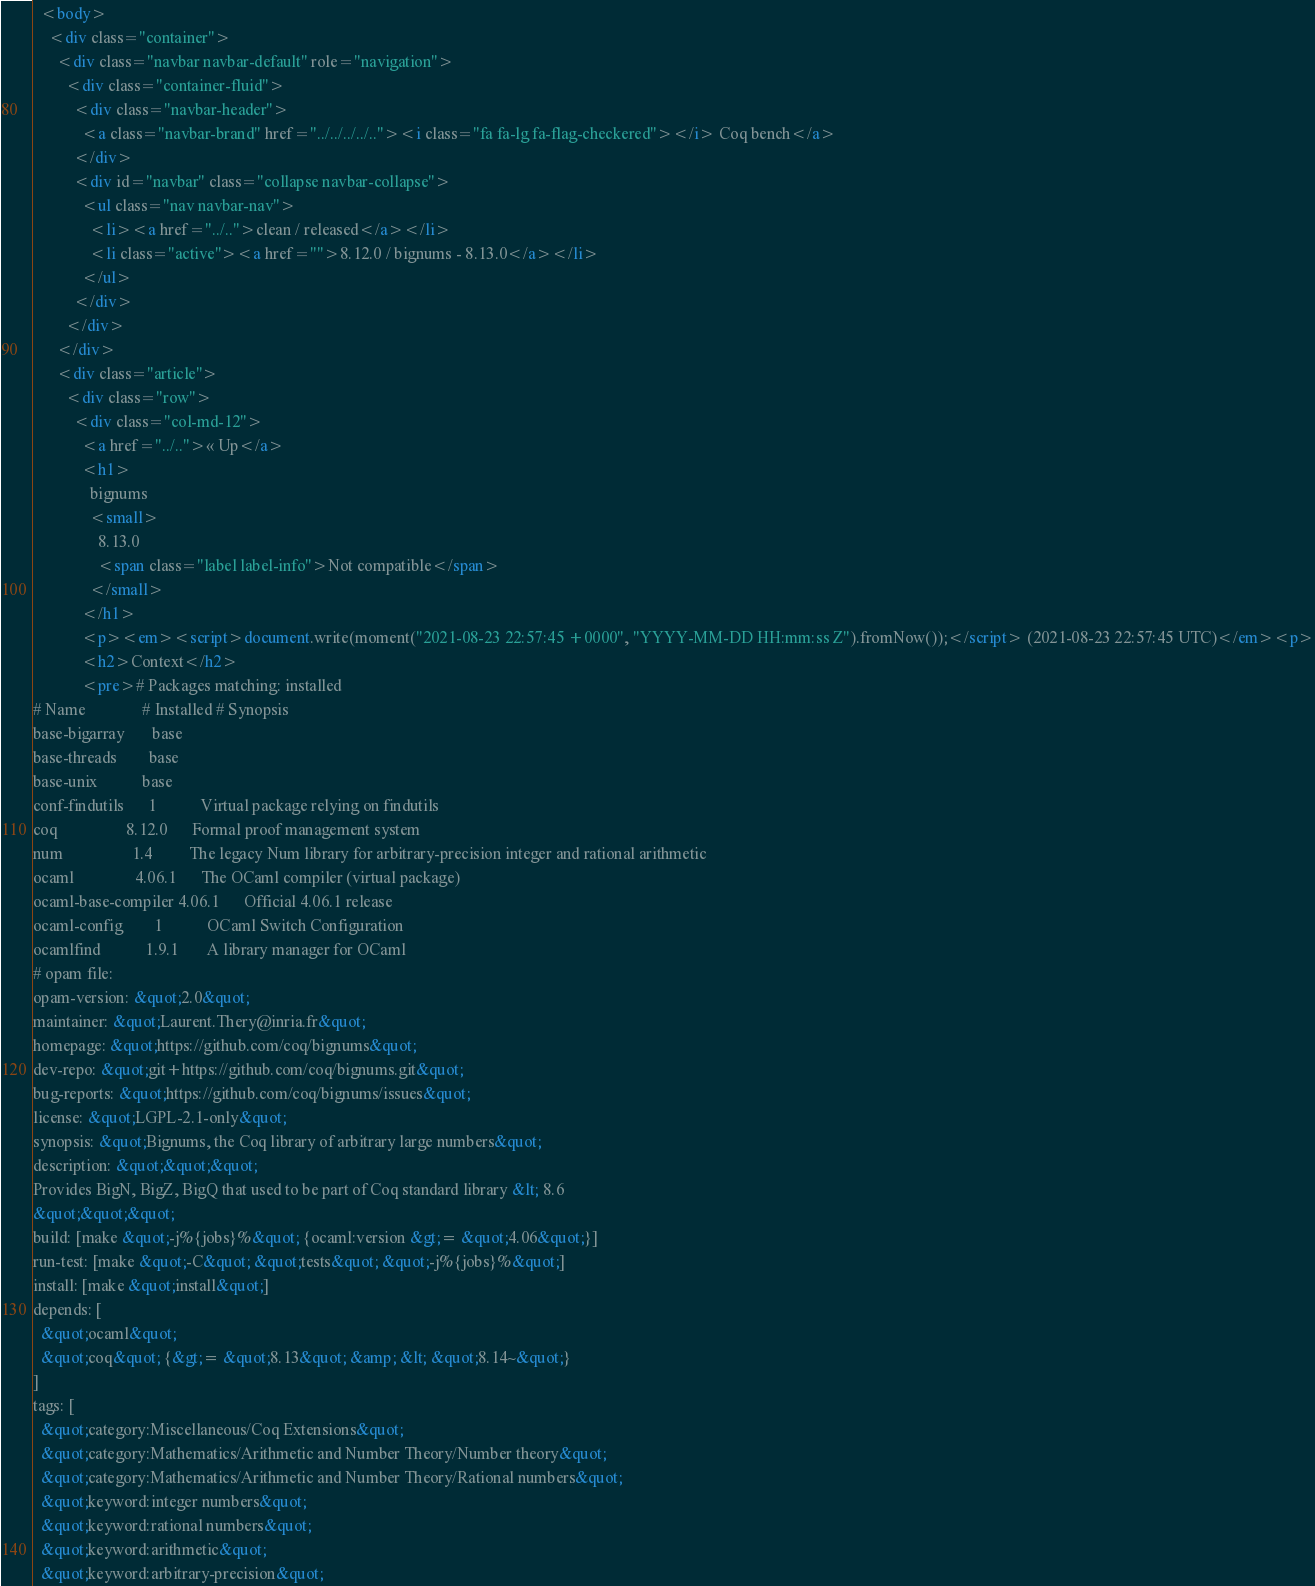<code> <loc_0><loc_0><loc_500><loc_500><_HTML_>  <body>
    <div class="container">
      <div class="navbar navbar-default" role="navigation">
        <div class="container-fluid">
          <div class="navbar-header">
            <a class="navbar-brand" href="../../../../.."><i class="fa fa-lg fa-flag-checkered"></i> Coq bench</a>
          </div>
          <div id="navbar" class="collapse navbar-collapse">
            <ul class="nav navbar-nav">
              <li><a href="../..">clean / released</a></li>
              <li class="active"><a href="">8.12.0 / bignums - 8.13.0</a></li>
            </ul>
          </div>
        </div>
      </div>
      <div class="article">
        <div class="row">
          <div class="col-md-12">
            <a href="../..">« Up</a>
            <h1>
              bignums
              <small>
                8.13.0
                <span class="label label-info">Not compatible</span>
              </small>
            </h1>
            <p><em><script>document.write(moment("2021-08-23 22:57:45 +0000", "YYYY-MM-DD HH:mm:ss Z").fromNow());</script> (2021-08-23 22:57:45 UTC)</em><p>
            <h2>Context</h2>
            <pre># Packages matching: installed
# Name              # Installed # Synopsis
base-bigarray       base
base-threads        base
base-unix           base
conf-findutils      1           Virtual package relying on findutils
coq                 8.12.0      Formal proof management system
num                 1.4         The legacy Num library for arbitrary-precision integer and rational arithmetic
ocaml               4.06.1      The OCaml compiler (virtual package)
ocaml-base-compiler 4.06.1      Official 4.06.1 release
ocaml-config        1           OCaml Switch Configuration
ocamlfind           1.9.1       A library manager for OCaml
# opam file:
opam-version: &quot;2.0&quot;
maintainer: &quot;Laurent.Thery@inria.fr&quot;
homepage: &quot;https://github.com/coq/bignums&quot;
dev-repo: &quot;git+https://github.com/coq/bignums.git&quot;
bug-reports: &quot;https://github.com/coq/bignums/issues&quot;
license: &quot;LGPL-2.1-only&quot;
synopsis: &quot;Bignums, the Coq library of arbitrary large numbers&quot;
description: &quot;&quot;&quot;
Provides BigN, BigZ, BigQ that used to be part of Coq standard library &lt; 8.6
&quot;&quot;&quot;
build: [make &quot;-j%{jobs}%&quot; {ocaml:version &gt;= &quot;4.06&quot;}]
run-test: [make &quot;-C&quot; &quot;tests&quot; &quot;-j%{jobs}%&quot;]
install: [make &quot;install&quot;]
depends: [
  &quot;ocaml&quot;
  &quot;coq&quot; {&gt;= &quot;8.13&quot; &amp; &lt; &quot;8.14~&quot;}
]
tags: [
  &quot;category:Miscellaneous/Coq Extensions&quot;
  &quot;category:Mathematics/Arithmetic and Number Theory/Number theory&quot;
  &quot;category:Mathematics/Arithmetic and Number Theory/Rational numbers&quot;
  &quot;keyword:integer numbers&quot;
  &quot;keyword:rational numbers&quot;
  &quot;keyword:arithmetic&quot;
  &quot;keyword:arbitrary-precision&quot;</code> 